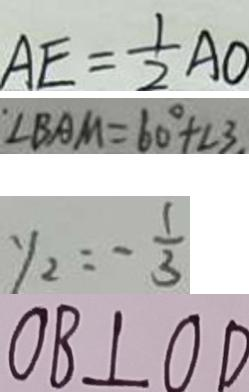Convert formula to latex. <formula><loc_0><loc_0><loc_500><loc_500>A E = \frac { 1 } { 2 } A O 
 \angle B A M = 6 0 ^ { \circ } + \angle 3 
 y _ { 2 } = - \frac { 1 } { 3 } 
 O B \bot O D</formula> 